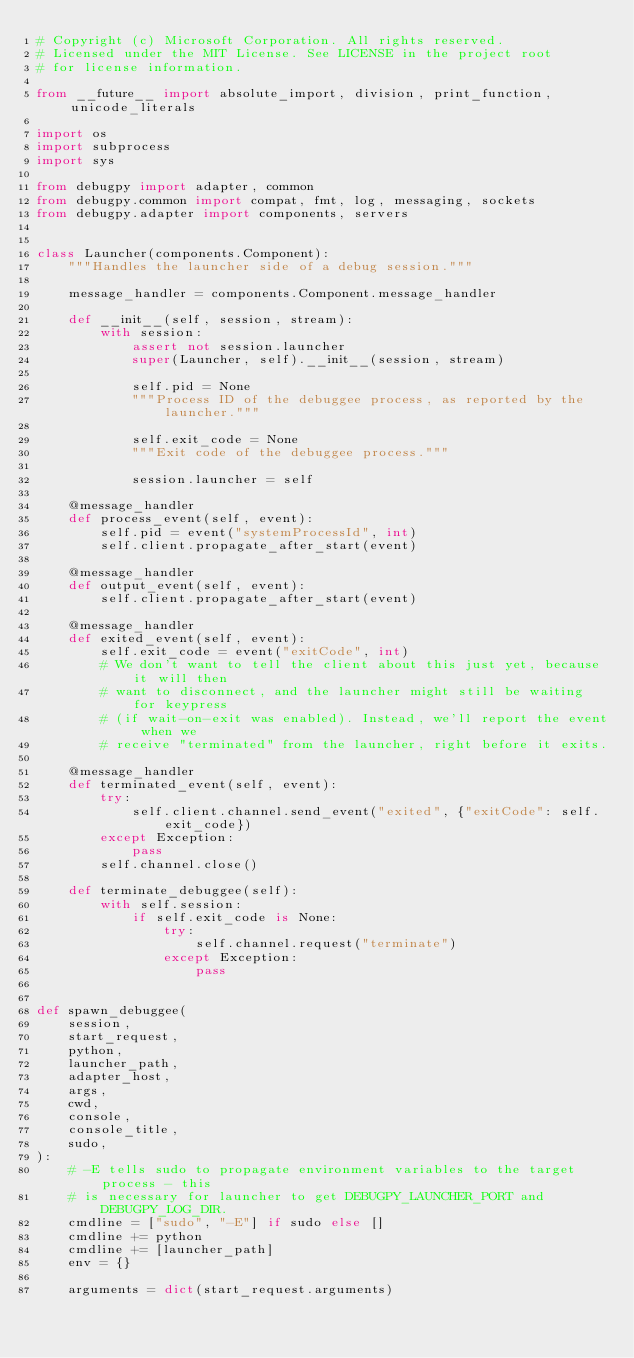Convert code to text. <code><loc_0><loc_0><loc_500><loc_500><_Python_># Copyright (c) Microsoft Corporation. All rights reserved.
# Licensed under the MIT License. See LICENSE in the project root
# for license information.

from __future__ import absolute_import, division, print_function, unicode_literals

import os
import subprocess
import sys

from debugpy import adapter, common
from debugpy.common import compat, fmt, log, messaging, sockets
from debugpy.adapter import components, servers


class Launcher(components.Component):
    """Handles the launcher side of a debug session."""

    message_handler = components.Component.message_handler

    def __init__(self, session, stream):
        with session:
            assert not session.launcher
            super(Launcher, self).__init__(session, stream)

            self.pid = None
            """Process ID of the debuggee process, as reported by the launcher."""

            self.exit_code = None
            """Exit code of the debuggee process."""

            session.launcher = self

    @message_handler
    def process_event(self, event):
        self.pid = event("systemProcessId", int)
        self.client.propagate_after_start(event)

    @message_handler
    def output_event(self, event):
        self.client.propagate_after_start(event)

    @message_handler
    def exited_event(self, event):
        self.exit_code = event("exitCode", int)
        # We don't want to tell the client about this just yet, because it will then
        # want to disconnect, and the launcher might still be waiting for keypress
        # (if wait-on-exit was enabled). Instead, we'll report the event when we
        # receive "terminated" from the launcher, right before it exits.

    @message_handler
    def terminated_event(self, event):
        try:
            self.client.channel.send_event("exited", {"exitCode": self.exit_code})
        except Exception:
            pass
        self.channel.close()

    def terminate_debuggee(self):
        with self.session:
            if self.exit_code is None:
                try:
                    self.channel.request("terminate")
                except Exception:
                    pass


def spawn_debuggee(
    session,
    start_request,
    python,
    launcher_path,
    adapter_host,
    args,
    cwd,
    console,
    console_title,
    sudo,
):
    # -E tells sudo to propagate environment variables to the target process - this
    # is necessary for launcher to get DEBUGPY_LAUNCHER_PORT and DEBUGPY_LOG_DIR.
    cmdline = ["sudo", "-E"] if sudo else []
    cmdline += python
    cmdline += [launcher_path]
    env = {}

    arguments = dict(start_request.arguments)</code> 